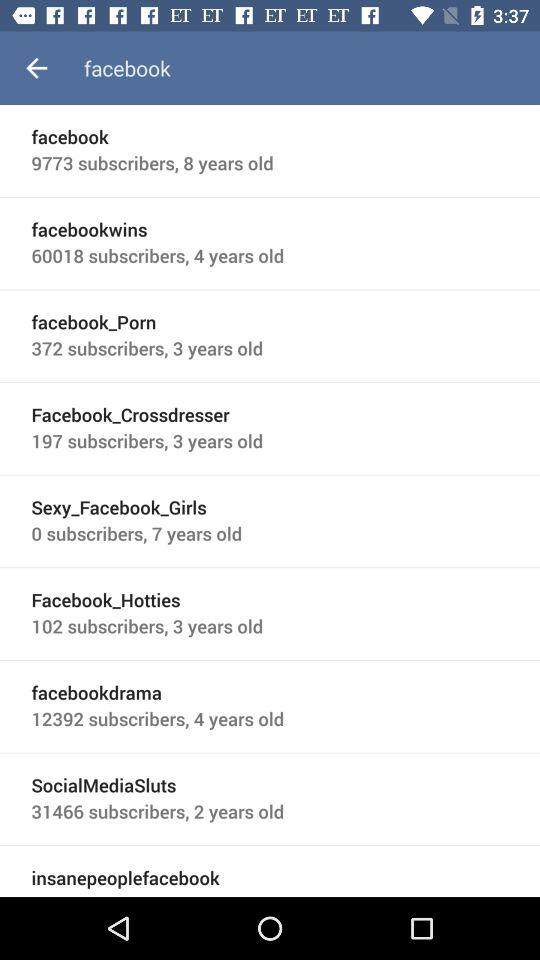How many subscribers are there of "facebookdrama"? There are 12392 subscribers. 